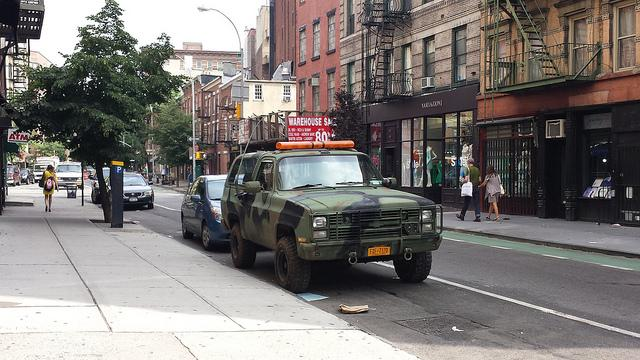Why does the truck have sign on top? advertising 